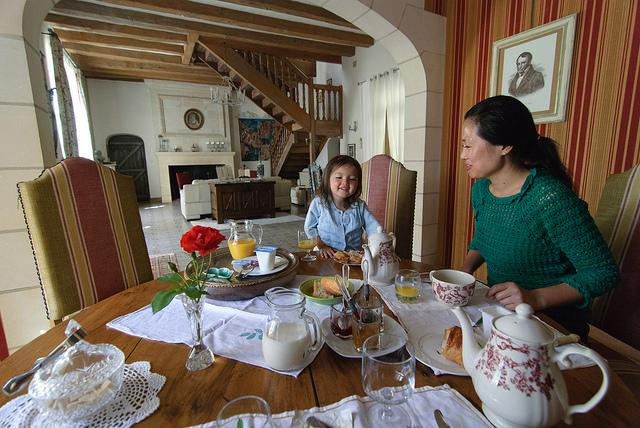Where does porcelain originally come from?

Choices:
A) italy
B) france
C) australia
D) china china 